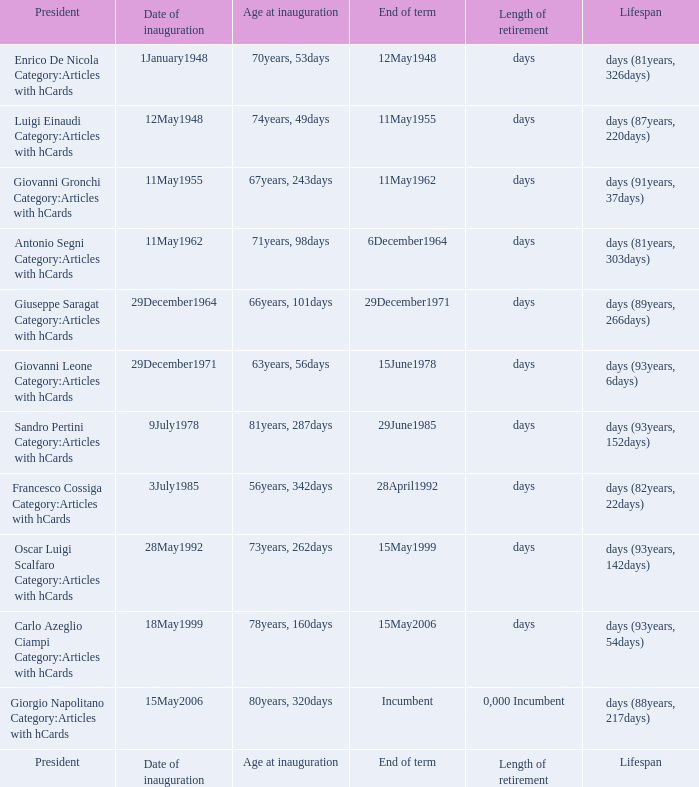What is the End of term of the President with an Age at inauguration of 78years, 160days? 15May2006. 